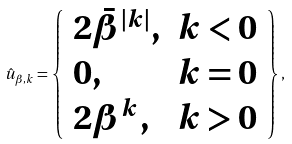Convert formula to latex. <formula><loc_0><loc_0><loc_500><loc_500>\hat { u } _ { \beta , k } = \left \{ \begin{array} { l l } 2 \bar { \beta } ^ { | k | } , & k < 0 \\ 0 , & k = 0 \\ 2 \beta ^ { k } , & k > 0 \end{array} \right \} ,</formula> 